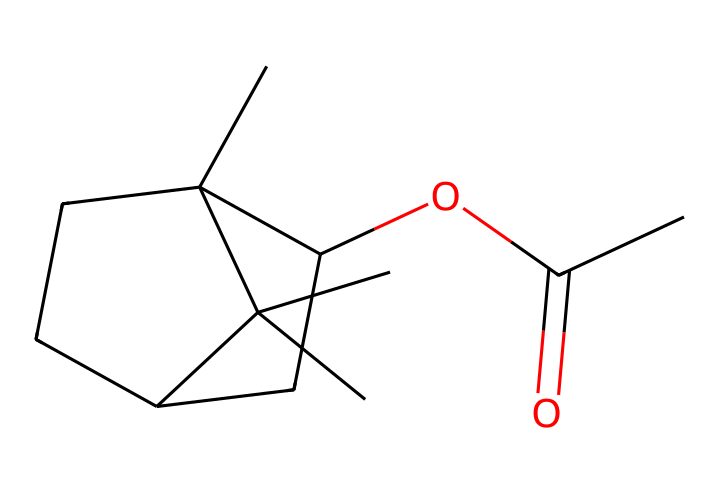how many carbon atoms are in this compound? The SMILES structure shows 'C' for carbon, and by counting all the carbon atoms in the structure, including those in branches and rings, we can determine the total. There are 12 carbon atoms represented.
Answer: twelve what is the functional group in this compound? The structure contains the 'CC(=O)O' portion, which indicates that it has an acetate functional group. When we identify the carbonyl (C=O) and the alkoxy (-O-), we confirm that it is an ester.
Answer: ester how many double bonds are present in this chemical? Upon examining the SMILES representation, the 'C(=O)' indicates a double bond between the carbon and oxygen. This chemical has only one such double bond in its structure.
Answer: one what type of chemical compound is this molecule classified as? Given the ester functional group and the presence of organic carbon-based structures, this molecule can be classified as an organic ester.
Answer: organic ester what is the degree of saturation for this compound? The degree of saturation can be calculated based on the number of rings and double bonds. This compound has one double bond and contains cyclic structures. Therefore, the degree of saturation would be four.
Answer: four what type of fragrance notes could this compound produce? The presence of ester functional groups often indicates fruity or sweet notes in fragrances. Therefore, this compound could be expected to produce fruity fragrance notes.
Answer: fruity 